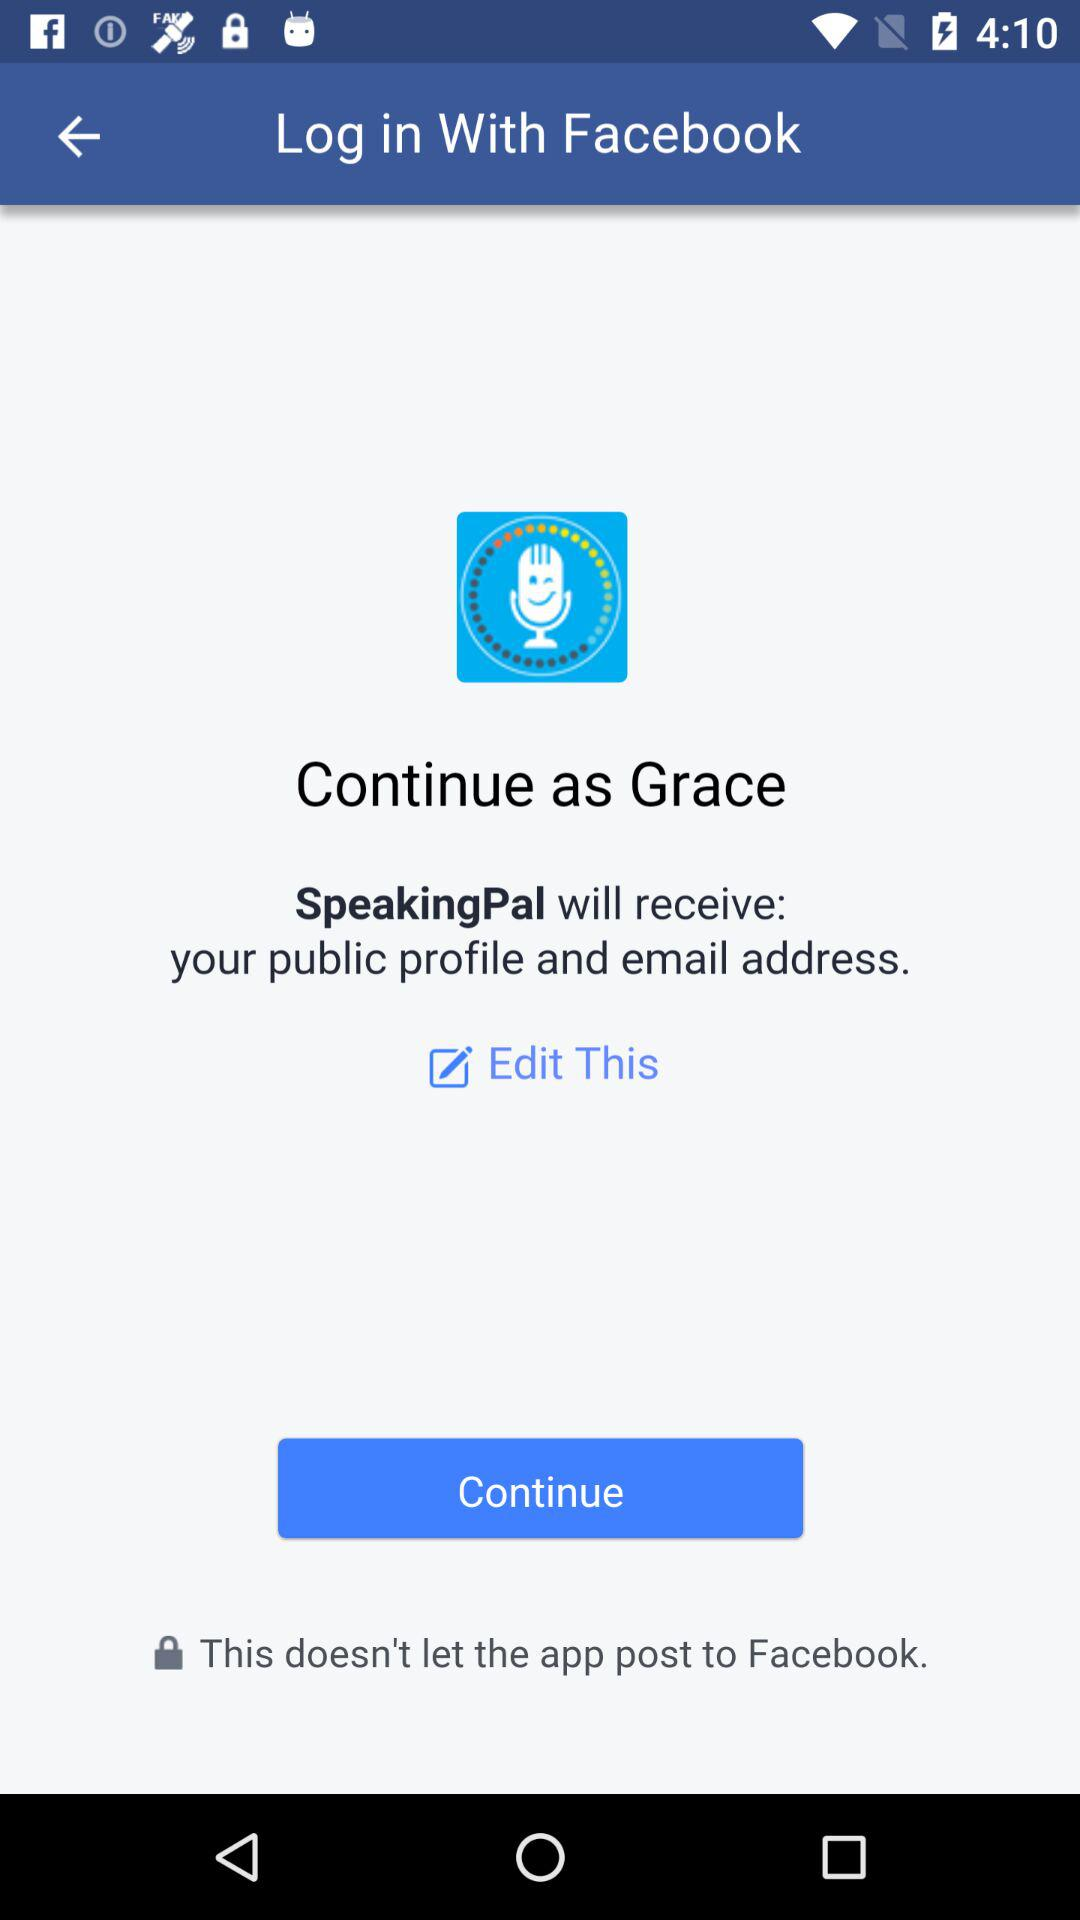What is the name of the application we are accessing? The application we are accessing is "Facebook". 